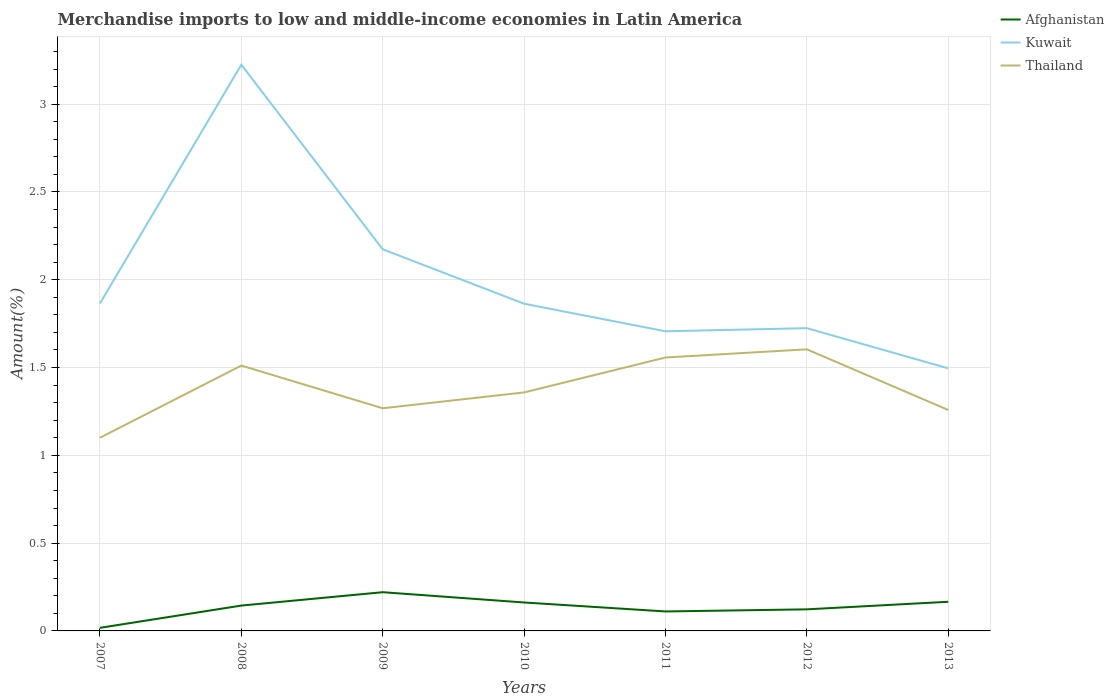Across all years, what is the maximum percentage of amount earned from merchandise imports in Afghanistan?
Your answer should be compact. 0.02. What is the total percentage of amount earned from merchandise imports in Thailand in the graph?
Provide a short and direct response. -0.34. What is the difference between the highest and the second highest percentage of amount earned from merchandise imports in Kuwait?
Ensure brevity in your answer.  1.73. What is the difference between the highest and the lowest percentage of amount earned from merchandise imports in Afghanistan?
Provide a succinct answer. 4. Are the values on the major ticks of Y-axis written in scientific E-notation?
Make the answer very short. No. Does the graph contain any zero values?
Offer a very short reply. No. Does the graph contain grids?
Your answer should be very brief. Yes. Where does the legend appear in the graph?
Give a very brief answer. Top right. What is the title of the graph?
Provide a succinct answer. Merchandise imports to low and middle-income economies in Latin America. What is the label or title of the Y-axis?
Your response must be concise. Amount(%). What is the Amount(%) of Afghanistan in 2007?
Ensure brevity in your answer.  0.02. What is the Amount(%) in Kuwait in 2007?
Provide a short and direct response. 1.87. What is the Amount(%) in Thailand in 2007?
Provide a succinct answer. 1.1. What is the Amount(%) of Afghanistan in 2008?
Make the answer very short. 0.14. What is the Amount(%) of Kuwait in 2008?
Make the answer very short. 3.22. What is the Amount(%) in Thailand in 2008?
Offer a very short reply. 1.51. What is the Amount(%) of Afghanistan in 2009?
Offer a terse response. 0.22. What is the Amount(%) in Kuwait in 2009?
Make the answer very short. 2.17. What is the Amount(%) in Thailand in 2009?
Ensure brevity in your answer.  1.27. What is the Amount(%) in Afghanistan in 2010?
Your response must be concise. 0.16. What is the Amount(%) in Kuwait in 2010?
Offer a very short reply. 1.86. What is the Amount(%) of Thailand in 2010?
Offer a terse response. 1.36. What is the Amount(%) in Afghanistan in 2011?
Ensure brevity in your answer.  0.11. What is the Amount(%) of Kuwait in 2011?
Your answer should be compact. 1.71. What is the Amount(%) of Thailand in 2011?
Your answer should be compact. 1.56. What is the Amount(%) in Afghanistan in 2012?
Offer a very short reply. 0.12. What is the Amount(%) of Kuwait in 2012?
Keep it short and to the point. 1.72. What is the Amount(%) of Thailand in 2012?
Provide a short and direct response. 1.6. What is the Amount(%) in Afghanistan in 2013?
Make the answer very short. 0.17. What is the Amount(%) in Kuwait in 2013?
Provide a short and direct response. 1.5. What is the Amount(%) in Thailand in 2013?
Your response must be concise. 1.26. Across all years, what is the maximum Amount(%) in Afghanistan?
Provide a succinct answer. 0.22. Across all years, what is the maximum Amount(%) in Kuwait?
Give a very brief answer. 3.22. Across all years, what is the maximum Amount(%) in Thailand?
Your response must be concise. 1.6. Across all years, what is the minimum Amount(%) in Afghanistan?
Ensure brevity in your answer.  0.02. Across all years, what is the minimum Amount(%) of Kuwait?
Provide a succinct answer. 1.5. Across all years, what is the minimum Amount(%) in Thailand?
Give a very brief answer. 1.1. What is the total Amount(%) in Afghanistan in the graph?
Ensure brevity in your answer.  0.94. What is the total Amount(%) in Kuwait in the graph?
Your answer should be compact. 14.05. What is the total Amount(%) of Thailand in the graph?
Your answer should be compact. 9.66. What is the difference between the Amount(%) in Afghanistan in 2007 and that in 2008?
Your answer should be compact. -0.13. What is the difference between the Amount(%) of Kuwait in 2007 and that in 2008?
Give a very brief answer. -1.36. What is the difference between the Amount(%) of Thailand in 2007 and that in 2008?
Ensure brevity in your answer.  -0.41. What is the difference between the Amount(%) of Afghanistan in 2007 and that in 2009?
Offer a very short reply. -0.2. What is the difference between the Amount(%) of Kuwait in 2007 and that in 2009?
Your answer should be compact. -0.31. What is the difference between the Amount(%) of Thailand in 2007 and that in 2009?
Make the answer very short. -0.17. What is the difference between the Amount(%) in Afghanistan in 2007 and that in 2010?
Offer a terse response. -0.14. What is the difference between the Amount(%) in Kuwait in 2007 and that in 2010?
Give a very brief answer. 0. What is the difference between the Amount(%) in Thailand in 2007 and that in 2010?
Your response must be concise. -0.26. What is the difference between the Amount(%) of Afghanistan in 2007 and that in 2011?
Keep it short and to the point. -0.09. What is the difference between the Amount(%) in Kuwait in 2007 and that in 2011?
Make the answer very short. 0.16. What is the difference between the Amount(%) in Thailand in 2007 and that in 2011?
Ensure brevity in your answer.  -0.46. What is the difference between the Amount(%) in Afghanistan in 2007 and that in 2012?
Your answer should be compact. -0.11. What is the difference between the Amount(%) of Kuwait in 2007 and that in 2012?
Ensure brevity in your answer.  0.14. What is the difference between the Amount(%) in Thailand in 2007 and that in 2012?
Offer a terse response. -0.5. What is the difference between the Amount(%) of Afghanistan in 2007 and that in 2013?
Offer a terse response. -0.15. What is the difference between the Amount(%) in Kuwait in 2007 and that in 2013?
Keep it short and to the point. 0.37. What is the difference between the Amount(%) in Thailand in 2007 and that in 2013?
Offer a very short reply. -0.16. What is the difference between the Amount(%) of Afghanistan in 2008 and that in 2009?
Offer a terse response. -0.08. What is the difference between the Amount(%) in Kuwait in 2008 and that in 2009?
Your answer should be very brief. 1.05. What is the difference between the Amount(%) of Thailand in 2008 and that in 2009?
Your answer should be compact. 0.24. What is the difference between the Amount(%) in Afghanistan in 2008 and that in 2010?
Your response must be concise. -0.02. What is the difference between the Amount(%) of Kuwait in 2008 and that in 2010?
Provide a short and direct response. 1.36. What is the difference between the Amount(%) of Thailand in 2008 and that in 2010?
Provide a short and direct response. 0.15. What is the difference between the Amount(%) of Afghanistan in 2008 and that in 2011?
Keep it short and to the point. 0.03. What is the difference between the Amount(%) in Kuwait in 2008 and that in 2011?
Provide a succinct answer. 1.52. What is the difference between the Amount(%) of Thailand in 2008 and that in 2011?
Ensure brevity in your answer.  -0.05. What is the difference between the Amount(%) in Afghanistan in 2008 and that in 2012?
Your answer should be very brief. 0.02. What is the difference between the Amount(%) of Kuwait in 2008 and that in 2012?
Your response must be concise. 1.5. What is the difference between the Amount(%) in Thailand in 2008 and that in 2012?
Keep it short and to the point. -0.09. What is the difference between the Amount(%) of Afghanistan in 2008 and that in 2013?
Offer a terse response. -0.02. What is the difference between the Amount(%) in Kuwait in 2008 and that in 2013?
Your answer should be compact. 1.73. What is the difference between the Amount(%) of Thailand in 2008 and that in 2013?
Keep it short and to the point. 0.25. What is the difference between the Amount(%) in Afghanistan in 2009 and that in 2010?
Offer a terse response. 0.06. What is the difference between the Amount(%) in Kuwait in 2009 and that in 2010?
Your answer should be compact. 0.31. What is the difference between the Amount(%) in Thailand in 2009 and that in 2010?
Offer a very short reply. -0.09. What is the difference between the Amount(%) in Afghanistan in 2009 and that in 2011?
Offer a very short reply. 0.11. What is the difference between the Amount(%) in Kuwait in 2009 and that in 2011?
Offer a terse response. 0.47. What is the difference between the Amount(%) in Thailand in 2009 and that in 2011?
Your answer should be very brief. -0.29. What is the difference between the Amount(%) of Afghanistan in 2009 and that in 2012?
Provide a short and direct response. 0.1. What is the difference between the Amount(%) in Kuwait in 2009 and that in 2012?
Give a very brief answer. 0.45. What is the difference between the Amount(%) in Thailand in 2009 and that in 2012?
Offer a very short reply. -0.34. What is the difference between the Amount(%) in Afghanistan in 2009 and that in 2013?
Give a very brief answer. 0.05. What is the difference between the Amount(%) of Kuwait in 2009 and that in 2013?
Ensure brevity in your answer.  0.68. What is the difference between the Amount(%) in Thailand in 2009 and that in 2013?
Your answer should be compact. 0.01. What is the difference between the Amount(%) of Afghanistan in 2010 and that in 2011?
Offer a terse response. 0.05. What is the difference between the Amount(%) in Kuwait in 2010 and that in 2011?
Your answer should be compact. 0.16. What is the difference between the Amount(%) in Thailand in 2010 and that in 2011?
Make the answer very short. -0.2. What is the difference between the Amount(%) in Afghanistan in 2010 and that in 2012?
Make the answer very short. 0.04. What is the difference between the Amount(%) in Kuwait in 2010 and that in 2012?
Offer a terse response. 0.14. What is the difference between the Amount(%) in Thailand in 2010 and that in 2012?
Your answer should be compact. -0.25. What is the difference between the Amount(%) of Afghanistan in 2010 and that in 2013?
Offer a very short reply. -0. What is the difference between the Amount(%) in Kuwait in 2010 and that in 2013?
Keep it short and to the point. 0.37. What is the difference between the Amount(%) of Thailand in 2010 and that in 2013?
Your answer should be very brief. 0.1. What is the difference between the Amount(%) of Afghanistan in 2011 and that in 2012?
Your answer should be very brief. -0.01. What is the difference between the Amount(%) of Kuwait in 2011 and that in 2012?
Your answer should be compact. -0.02. What is the difference between the Amount(%) of Thailand in 2011 and that in 2012?
Keep it short and to the point. -0.05. What is the difference between the Amount(%) in Afghanistan in 2011 and that in 2013?
Give a very brief answer. -0.06. What is the difference between the Amount(%) in Kuwait in 2011 and that in 2013?
Provide a short and direct response. 0.21. What is the difference between the Amount(%) of Thailand in 2011 and that in 2013?
Ensure brevity in your answer.  0.3. What is the difference between the Amount(%) in Afghanistan in 2012 and that in 2013?
Offer a very short reply. -0.04. What is the difference between the Amount(%) in Kuwait in 2012 and that in 2013?
Offer a very short reply. 0.23. What is the difference between the Amount(%) in Thailand in 2012 and that in 2013?
Ensure brevity in your answer.  0.35. What is the difference between the Amount(%) in Afghanistan in 2007 and the Amount(%) in Kuwait in 2008?
Ensure brevity in your answer.  -3.21. What is the difference between the Amount(%) of Afghanistan in 2007 and the Amount(%) of Thailand in 2008?
Make the answer very short. -1.49. What is the difference between the Amount(%) of Kuwait in 2007 and the Amount(%) of Thailand in 2008?
Your response must be concise. 0.35. What is the difference between the Amount(%) in Afghanistan in 2007 and the Amount(%) in Kuwait in 2009?
Provide a succinct answer. -2.16. What is the difference between the Amount(%) of Afghanistan in 2007 and the Amount(%) of Thailand in 2009?
Provide a short and direct response. -1.25. What is the difference between the Amount(%) in Kuwait in 2007 and the Amount(%) in Thailand in 2009?
Provide a succinct answer. 0.6. What is the difference between the Amount(%) in Afghanistan in 2007 and the Amount(%) in Kuwait in 2010?
Your answer should be compact. -1.85. What is the difference between the Amount(%) of Afghanistan in 2007 and the Amount(%) of Thailand in 2010?
Give a very brief answer. -1.34. What is the difference between the Amount(%) of Kuwait in 2007 and the Amount(%) of Thailand in 2010?
Provide a succinct answer. 0.51. What is the difference between the Amount(%) in Afghanistan in 2007 and the Amount(%) in Kuwait in 2011?
Offer a terse response. -1.69. What is the difference between the Amount(%) of Afghanistan in 2007 and the Amount(%) of Thailand in 2011?
Offer a terse response. -1.54. What is the difference between the Amount(%) of Kuwait in 2007 and the Amount(%) of Thailand in 2011?
Give a very brief answer. 0.31. What is the difference between the Amount(%) of Afghanistan in 2007 and the Amount(%) of Kuwait in 2012?
Ensure brevity in your answer.  -1.71. What is the difference between the Amount(%) of Afghanistan in 2007 and the Amount(%) of Thailand in 2012?
Make the answer very short. -1.59. What is the difference between the Amount(%) of Kuwait in 2007 and the Amount(%) of Thailand in 2012?
Your answer should be compact. 0.26. What is the difference between the Amount(%) in Afghanistan in 2007 and the Amount(%) in Kuwait in 2013?
Keep it short and to the point. -1.48. What is the difference between the Amount(%) in Afghanistan in 2007 and the Amount(%) in Thailand in 2013?
Provide a short and direct response. -1.24. What is the difference between the Amount(%) in Kuwait in 2007 and the Amount(%) in Thailand in 2013?
Offer a terse response. 0.61. What is the difference between the Amount(%) of Afghanistan in 2008 and the Amount(%) of Kuwait in 2009?
Your answer should be very brief. -2.03. What is the difference between the Amount(%) in Afghanistan in 2008 and the Amount(%) in Thailand in 2009?
Provide a succinct answer. -1.12. What is the difference between the Amount(%) of Kuwait in 2008 and the Amount(%) of Thailand in 2009?
Make the answer very short. 1.96. What is the difference between the Amount(%) in Afghanistan in 2008 and the Amount(%) in Kuwait in 2010?
Offer a very short reply. -1.72. What is the difference between the Amount(%) of Afghanistan in 2008 and the Amount(%) of Thailand in 2010?
Give a very brief answer. -1.21. What is the difference between the Amount(%) in Kuwait in 2008 and the Amount(%) in Thailand in 2010?
Offer a very short reply. 1.87. What is the difference between the Amount(%) of Afghanistan in 2008 and the Amount(%) of Kuwait in 2011?
Your response must be concise. -1.56. What is the difference between the Amount(%) of Afghanistan in 2008 and the Amount(%) of Thailand in 2011?
Make the answer very short. -1.41. What is the difference between the Amount(%) of Kuwait in 2008 and the Amount(%) of Thailand in 2011?
Provide a short and direct response. 1.67. What is the difference between the Amount(%) of Afghanistan in 2008 and the Amount(%) of Kuwait in 2012?
Offer a very short reply. -1.58. What is the difference between the Amount(%) of Afghanistan in 2008 and the Amount(%) of Thailand in 2012?
Ensure brevity in your answer.  -1.46. What is the difference between the Amount(%) of Kuwait in 2008 and the Amount(%) of Thailand in 2012?
Provide a short and direct response. 1.62. What is the difference between the Amount(%) of Afghanistan in 2008 and the Amount(%) of Kuwait in 2013?
Offer a very short reply. -1.35. What is the difference between the Amount(%) in Afghanistan in 2008 and the Amount(%) in Thailand in 2013?
Keep it short and to the point. -1.11. What is the difference between the Amount(%) in Kuwait in 2008 and the Amount(%) in Thailand in 2013?
Give a very brief answer. 1.97. What is the difference between the Amount(%) in Afghanistan in 2009 and the Amount(%) in Kuwait in 2010?
Your answer should be very brief. -1.64. What is the difference between the Amount(%) of Afghanistan in 2009 and the Amount(%) of Thailand in 2010?
Keep it short and to the point. -1.14. What is the difference between the Amount(%) in Kuwait in 2009 and the Amount(%) in Thailand in 2010?
Give a very brief answer. 0.82. What is the difference between the Amount(%) of Afghanistan in 2009 and the Amount(%) of Kuwait in 2011?
Offer a terse response. -1.49. What is the difference between the Amount(%) in Afghanistan in 2009 and the Amount(%) in Thailand in 2011?
Offer a very short reply. -1.34. What is the difference between the Amount(%) in Kuwait in 2009 and the Amount(%) in Thailand in 2011?
Provide a short and direct response. 0.62. What is the difference between the Amount(%) in Afghanistan in 2009 and the Amount(%) in Kuwait in 2012?
Provide a succinct answer. -1.5. What is the difference between the Amount(%) in Afghanistan in 2009 and the Amount(%) in Thailand in 2012?
Keep it short and to the point. -1.38. What is the difference between the Amount(%) of Kuwait in 2009 and the Amount(%) of Thailand in 2012?
Keep it short and to the point. 0.57. What is the difference between the Amount(%) in Afghanistan in 2009 and the Amount(%) in Kuwait in 2013?
Offer a terse response. -1.28. What is the difference between the Amount(%) in Afghanistan in 2009 and the Amount(%) in Thailand in 2013?
Ensure brevity in your answer.  -1.04. What is the difference between the Amount(%) of Kuwait in 2009 and the Amount(%) of Thailand in 2013?
Provide a short and direct response. 0.92. What is the difference between the Amount(%) of Afghanistan in 2010 and the Amount(%) of Kuwait in 2011?
Your answer should be very brief. -1.54. What is the difference between the Amount(%) in Afghanistan in 2010 and the Amount(%) in Thailand in 2011?
Ensure brevity in your answer.  -1.4. What is the difference between the Amount(%) in Kuwait in 2010 and the Amount(%) in Thailand in 2011?
Provide a short and direct response. 0.31. What is the difference between the Amount(%) in Afghanistan in 2010 and the Amount(%) in Kuwait in 2012?
Make the answer very short. -1.56. What is the difference between the Amount(%) of Afghanistan in 2010 and the Amount(%) of Thailand in 2012?
Give a very brief answer. -1.44. What is the difference between the Amount(%) of Kuwait in 2010 and the Amount(%) of Thailand in 2012?
Keep it short and to the point. 0.26. What is the difference between the Amount(%) in Afghanistan in 2010 and the Amount(%) in Kuwait in 2013?
Your answer should be very brief. -1.33. What is the difference between the Amount(%) of Afghanistan in 2010 and the Amount(%) of Thailand in 2013?
Offer a very short reply. -1.1. What is the difference between the Amount(%) in Kuwait in 2010 and the Amount(%) in Thailand in 2013?
Ensure brevity in your answer.  0.61. What is the difference between the Amount(%) in Afghanistan in 2011 and the Amount(%) in Kuwait in 2012?
Provide a succinct answer. -1.61. What is the difference between the Amount(%) in Afghanistan in 2011 and the Amount(%) in Thailand in 2012?
Offer a very short reply. -1.49. What is the difference between the Amount(%) of Kuwait in 2011 and the Amount(%) of Thailand in 2012?
Offer a very short reply. 0.1. What is the difference between the Amount(%) in Afghanistan in 2011 and the Amount(%) in Kuwait in 2013?
Give a very brief answer. -1.38. What is the difference between the Amount(%) of Afghanistan in 2011 and the Amount(%) of Thailand in 2013?
Give a very brief answer. -1.15. What is the difference between the Amount(%) of Kuwait in 2011 and the Amount(%) of Thailand in 2013?
Offer a very short reply. 0.45. What is the difference between the Amount(%) in Afghanistan in 2012 and the Amount(%) in Kuwait in 2013?
Keep it short and to the point. -1.37. What is the difference between the Amount(%) in Afghanistan in 2012 and the Amount(%) in Thailand in 2013?
Offer a very short reply. -1.14. What is the difference between the Amount(%) of Kuwait in 2012 and the Amount(%) of Thailand in 2013?
Provide a short and direct response. 0.47. What is the average Amount(%) of Afghanistan per year?
Provide a succinct answer. 0.13. What is the average Amount(%) in Kuwait per year?
Offer a very short reply. 2.01. What is the average Amount(%) of Thailand per year?
Offer a terse response. 1.38. In the year 2007, what is the difference between the Amount(%) in Afghanistan and Amount(%) in Kuwait?
Ensure brevity in your answer.  -1.85. In the year 2007, what is the difference between the Amount(%) in Afghanistan and Amount(%) in Thailand?
Provide a short and direct response. -1.08. In the year 2007, what is the difference between the Amount(%) of Kuwait and Amount(%) of Thailand?
Provide a short and direct response. 0.77. In the year 2008, what is the difference between the Amount(%) in Afghanistan and Amount(%) in Kuwait?
Provide a short and direct response. -3.08. In the year 2008, what is the difference between the Amount(%) of Afghanistan and Amount(%) of Thailand?
Provide a short and direct response. -1.37. In the year 2008, what is the difference between the Amount(%) of Kuwait and Amount(%) of Thailand?
Offer a terse response. 1.71. In the year 2009, what is the difference between the Amount(%) in Afghanistan and Amount(%) in Kuwait?
Ensure brevity in your answer.  -1.95. In the year 2009, what is the difference between the Amount(%) in Afghanistan and Amount(%) in Thailand?
Provide a short and direct response. -1.05. In the year 2009, what is the difference between the Amount(%) in Kuwait and Amount(%) in Thailand?
Ensure brevity in your answer.  0.91. In the year 2010, what is the difference between the Amount(%) of Afghanistan and Amount(%) of Kuwait?
Give a very brief answer. -1.7. In the year 2010, what is the difference between the Amount(%) of Afghanistan and Amount(%) of Thailand?
Your answer should be very brief. -1.2. In the year 2010, what is the difference between the Amount(%) of Kuwait and Amount(%) of Thailand?
Your response must be concise. 0.51. In the year 2011, what is the difference between the Amount(%) of Afghanistan and Amount(%) of Kuwait?
Provide a short and direct response. -1.6. In the year 2011, what is the difference between the Amount(%) in Afghanistan and Amount(%) in Thailand?
Make the answer very short. -1.45. In the year 2011, what is the difference between the Amount(%) in Kuwait and Amount(%) in Thailand?
Make the answer very short. 0.15. In the year 2012, what is the difference between the Amount(%) in Afghanistan and Amount(%) in Kuwait?
Keep it short and to the point. -1.6. In the year 2012, what is the difference between the Amount(%) in Afghanistan and Amount(%) in Thailand?
Keep it short and to the point. -1.48. In the year 2012, what is the difference between the Amount(%) of Kuwait and Amount(%) of Thailand?
Provide a short and direct response. 0.12. In the year 2013, what is the difference between the Amount(%) in Afghanistan and Amount(%) in Kuwait?
Your answer should be compact. -1.33. In the year 2013, what is the difference between the Amount(%) in Afghanistan and Amount(%) in Thailand?
Your response must be concise. -1.09. In the year 2013, what is the difference between the Amount(%) of Kuwait and Amount(%) of Thailand?
Provide a succinct answer. 0.24. What is the ratio of the Amount(%) of Afghanistan in 2007 to that in 2008?
Offer a very short reply. 0.12. What is the ratio of the Amount(%) of Kuwait in 2007 to that in 2008?
Provide a succinct answer. 0.58. What is the ratio of the Amount(%) of Thailand in 2007 to that in 2008?
Keep it short and to the point. 0.73. What is the ratio of the Amount(%) in Afghanistan in 2007 to that in 2009?
Ensure brevity in your answer.  0.08. What is the ratio of the Amount(%) in Kuwait in 2007 to that in 2009?
Make the answer very short. 0.86. What is the ratio of the Amount(%) in Thailand in 2007 to that in 2009?
Your response must be concise. 0.87. What is the ratio of the Amount(%) in Afghanistan in 2007 to that in 2010?
Give a very brief answer. 0.11. What is the ratio of the Amount(%) in Kuwait in 2007 to that in 2010?
Provide a short and direct response. 1. What is the ratio of the Amount(%) in Thailand in 2007 to that in 2010?
Offer a terse response. 0.81. What is the ratio of the Amount(%) in Afghanistan in 2007 to that in 2011?
Provide a short and direct response. 0.16. What is the ratio of the Amount(%) of Kuwait in 2007 to that in 2011?
Offer a terse response. 1.09. What is the ratio of the Amount(%) of Thailand in 2007 to that in 2011?
Your response must be concise. 0.71. What is the ratio of the Amount(%) of Afghanistan in 2007 to that in 2012?
Offer a terse response. 0.14. What is the ratio of the Amount(%) of Kuwait in 2007 to that in 2012?
Offer a terse response. 1.08. What is the ratio of the Amount(%) in Thailand in 2007 to that in 2012?
Make the answer very short. 0.69. What is the ratio of the Amount(%) in Afghanistan in 2007 to that in 2013?
Keep it short and to the point. 0.11. What is the ratio of the Amount(%) in Kuwait in 2007 to that in 2013?
Ensure brevity in your answer.  1.25. What is the ratio of the Amount(%) of Thailand in 2007 to that in 2013?
Provide a succinct answer. 0.87. What is the ratio of the Amount(%) in Afghanistan in 2008 to that in 2009?
Offer a very short reply. 0.65. What is the ratio of the Amount(%) of Kuwait in 2008 to that in 2009?
Make the answer very short. 1.48. What is the ratio of the Amount(%) in Thailand in 2008 to that in 2009?
Provide a succinct answer. 1.19. What is the ratio of the Amount(%) of Afghanistan in 2008 to that in 2010?
Ensure brevity in your answer.  0.89. What is the ratio of the Amount(%) in Kuwait in 2008 to that in 2010?
Keep it short and to the point. 1.73. What is the ratio of the Amount(%) of Thailand in 2008 to that in 2010?
Offer a very short reply. 1.11. What is the ratio of the Amount(%) of Afghanistan in 2008 to that in 2011?
Your answer should be compact. 1.3. What is the ratio of the Amount(%) in Kuwait in 2008 to that in 2011?
Your response must be concise. 1.89. What is the ratio of the Amount(%) of Thailand in 2008 to that in 2011?
Your answer should be compact. 0.97. What is the ratio of the Amount(%) in Afghanistan in 2008 to that in 2012?
Make the answer very short. 1.17. What is the ratio of the Amount(%) in Kuwait in 2008 to that in 2012?
Ensure brevity in your answer.  1.87. What is the ratio of the Amount(%) of Thailand in 2008 to that in 2012?
Offer a very short reply. 0.94. What is the ratio of the Amount(%) of Afghanistan in 2008 to that in 2013?
Ensure brevity in your answer.  0.87. What is the ratio of the Amount(%) of Kuwait in 2008 to that in 2013?
Your answer should be very brief. 2.16. What is the ratio of the Amount(%) in Thailand in 2008 to that in 2013?
Give a very brief answer. 1.2. What is the ratio of the Amount(%) in Afghanistan in 2009 to that in 2010?
Your answer should be compact. 1.36. What is the ratio of the Amount(%) of Kuwait in 2009 to that in 2010?
Offer a very short reply. 1.17. What is the ratio of the Amount(%) in Thailand in 2009 to that in 2010?
Your response must be concise. 0.93. What is the ratio of the Amount(%) of Afghanistan in 2009 to that in 2011?
Provide a short and direct response. 1.99. What is the ratio of the Amount(%) of Kuwait in 2009 to that in 2011?
Provide a succinct answer. 1.27. What is the ratio of the Amount(%) in Thailand in 2009 to that in 2011?
Your answer should be compact. 0.81. What is the ratio of the Amount(%) in Afghanistan in 2009 to that in 2012?
Your answer should be very brief. 1.79. What is the ratio of the Amount(%) of Kuwait in 2009 to that in 2012?
Offer a terse response. 1.26. What is the ratio of the Amount(%) of Thailand in 2009 to that in 2012?
Offer a terse response. 0.79. What is the ratio of the Amount(%) of Afghanistan in 2009 to that in 2013?
Ensure brevity in your answer.  1.33. What is the ratio of the Amount(%) of Kuwait in 2009 to that in 2013?
Provide a short and direct response. 1.45. What is the ratio of the Amount(%) of Thailand in 2009 to that in 2013?
Your answer should be compact. 1.01. What is the ratio of the Amount(%) of Afghanistan in 2010 to that in 2011?
Ensure brevity in your answer.  1.46. What is the ratio of the Amount(%) in Kuwait in 2010 to that in 2011?
Provide a succinct answer. 1.09. What is the ratio of the Amount(%) in Thailand in 2010 to that in 2011?
Ensure brevity in your answer.  0.87. What is the ratio of the Amount(%) in Afghanistan in 2010 to that in 2012?
Provide a short and direct response. 1.32. What is the ratio of the Amount(%) of Kuwait in 2010 to that in 2012?
Your answer should be compact. 1.08. What is the ratio of the Amount(%) in Thailand in 2010 to that in 2012?
Make the answer very short. 0.85. What is the ratio of the Amount(%) in Afghanistan in 2010 to that in 2013?
Your answer should be very brief. 0.98. What is the ratio of the Amount(%) in Kuwait in 2010 to that in 2013?
Your answer should be very brief. 1.25. What is the ratio of the Amount(%) in Thailand in 2010 to that in 2013?
Your response must be concise. 1.08. What is the ratio of the Amount(%) in Afghanistan in 2011 to that in 2012?
Keep it short and to the point. 0.9. What is the ratio of the Amount(%) of Kuwait in 2011 to that in 2012?
Provide a short and direct response. 0.99. What is the ratio of the Amount(%) of Thailand in 2011 to that in 2012?
Provide a succinct answer. 0.97. What is the ratio of the Amount(%) of Afghanistan in 2011 to that in 2013?
Your answer should be very brief. 0.67. What is the ratio of the Amount(%) in Kuwait in 2011 to that in 2013?
Provide a short and direct response. 1.14. What is the ratio of the Amount(%) of Thailand in 2011 to that in 2013?
Provide a succinct answer. 1.24. What is the ratio of the Amount(%) of Afghanistan in 2012 to that in 2013?
Offer a terse response. 0.74. What is the ratio of the Amount(%) of Kuwait in 2012 to that in 2013?
Your response must be concise. 1.15. What is the ratio of the Amount(%) of Thailand in 2012 to that in 2013?
Your answer should be very brief. 1.27. What is the difference between the highest and the second highest Amount(%) in Afghanistan?
Provide a succinct answer. 0.05. What is the difference between the highest and the second highest Amount(%) in Kuwait?
Your answer should be compact. 1.05. What is the difference between the highest and the second highest Amount(%) in Thailand?
Your answer should be compact. 0.05. What is the difference between the highest and the lowest Amount(%) of Afghanistan?
Your answer should be very brief. 0.2. What is the difference between the highest and the lowest Amount(%) of Kuwait?
Your response must be concise. 1.73. What is the difference between the highest and the lowest Amount(%) in Thailand?
Offer a very short reply. 0.5. 